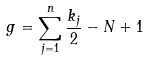Convert formula to latex. <formula><loc_0><loc_0><loc_500><loc_500>g = \sum _ { j = 1 } ^ { n } \frac { k _ { j } } { 2 } - N + 1</formula> 